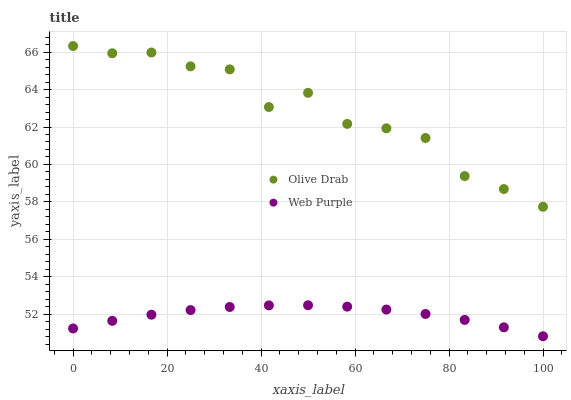Does Web Purple have the minimum area under the curve?
Answer yes or no. Yes. Does Olive Drab have the maximum area under the curve?
Answer yes or no. Yes. Does Olive Drab have the minimum area under the curve?
Answer yes or no. No. Is Web Purple the smoothest?
Answer yes or no. Yes. Is Olive Drab the roughest?
Answer yes or no. Yes. Is Olive Drab the smoothest?
Answer yes or no. No. Does Web Purple have the lowest value?
Answer yes or no. Yes. Does Olive Drab have the lowest value?
Answer yes or no. No. Does Olive Drab have the highest value?
Answer yes or no. Yes. Is Web Purple less than Olive Drab?
Answer yes or no. Yes. Is Olive Drab greater than Web Purple?
Answer yes or no. Yes. Does Web Purple intersect Olive Drab?
Answer yes or no. No. 